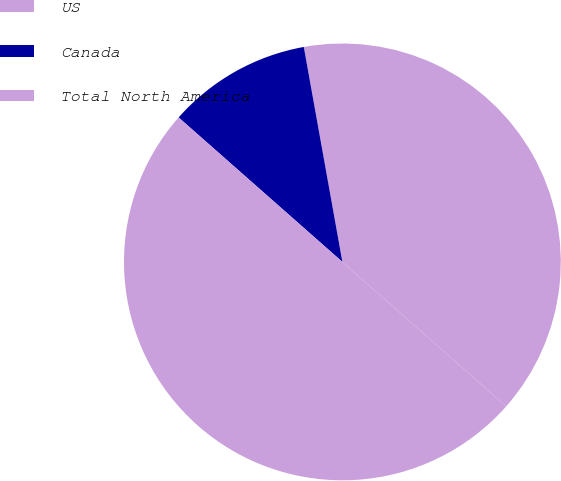<chart> <loc_0><loc_0><loc_500><loc_500><pie_chart><fcel>US<fcel>Canada<fcel>Total North America<nl><fcel>39.33%<fcel>10.67%<fcel>50.0%<nl></chart> 